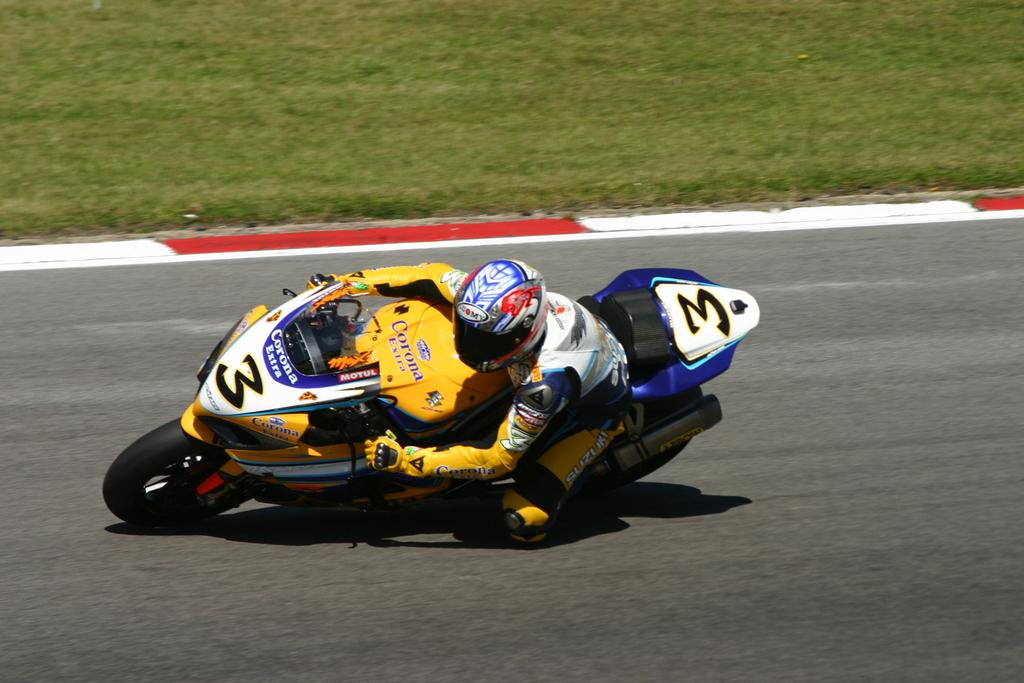What is the man in the image doing? The man is racing a bike in the image. What type of clothing is the man wearing? The man is wearing sports wear in the image. What safety gear is the man wearing while racing the bike? The man is wearing a helmet in the image. What type of surface can be seen in the image? There is a road in the image, and a grass surface behind the road. Can you tell me how many donkeys are present in the image? There are no donkeys present in the image. What type of maid is assisting the man in the image? There is no maid present in the image. 